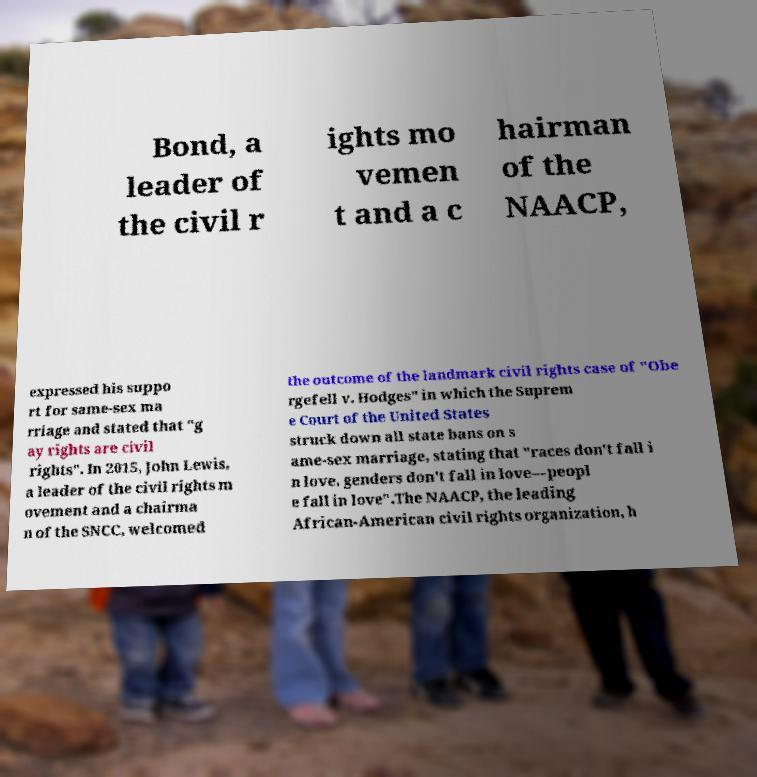For documentation purposes, I need the text within this image transcribed. Could you provide that? Bond, a leader of the civil r ights mo vemen t and a c hairman of the NAACP, expressed his suppo rt for same-sex ma rriage and stated that "g ay rights are civil rights". In 2015, John Lewis, a leader of the civil rights m ovement and a chairma n of the SNCC, welcomed the outcome of the landmark civil rights case of "Obe rgefell v. Hodges" in which the Suprem e Court of the United States struck down all state bans on s ame-sex marriage, stating that "races don't fall i n love, genders don't fall in love—peopl e fall in love".The NAACP, the leading African-American civil rights organization, h 